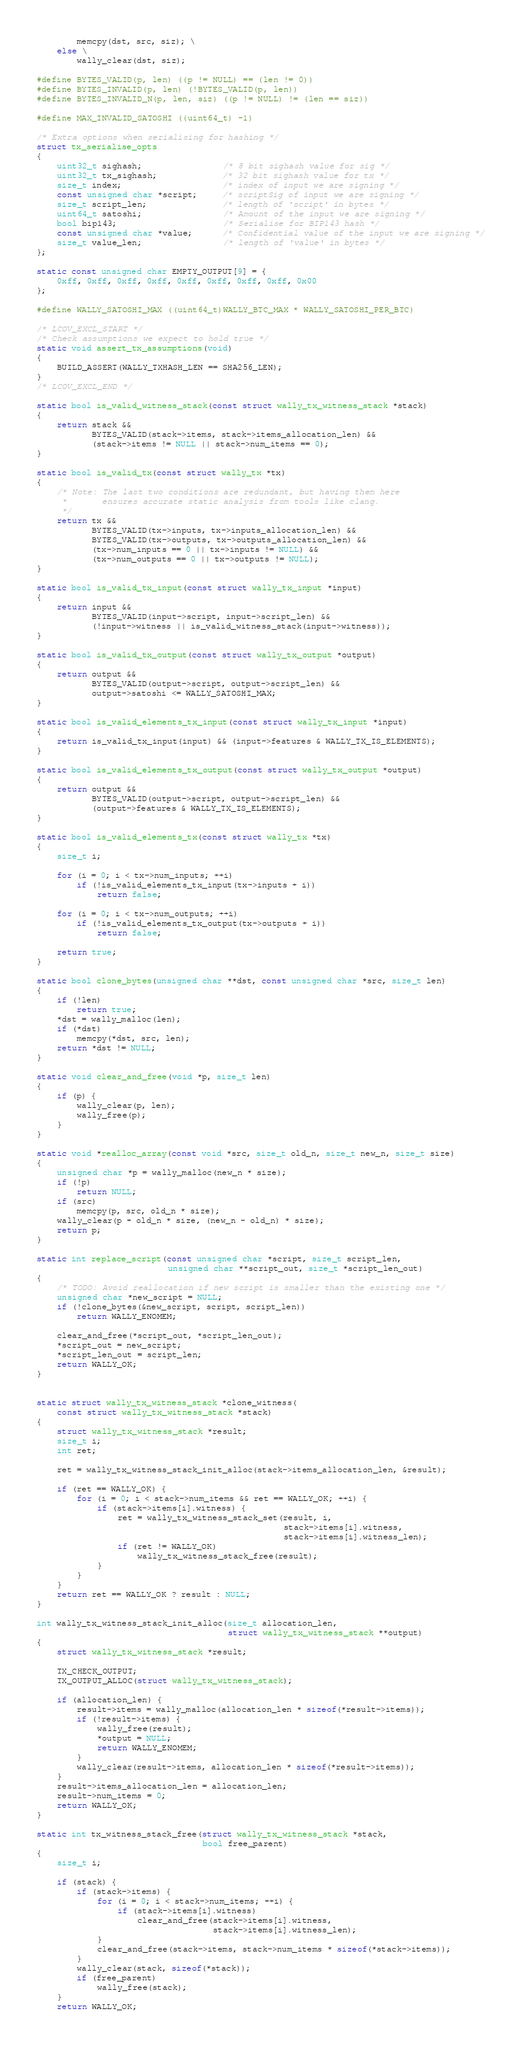<code> <loc_0><loc_0><loc_500><loc_500><_C_>        memcpy(dst, src, siz); \
    else \
        wally_clear(dst, siz);

#define BYTES_VALID(p, len) ((p != NULL) == (len != 0))
#define BYTES_INVALID(p, len) (!BYTES_VALID(p, len))
#define BYTES_INVALID_N(p, len, siz) ((p != NULL) != (len == siz))

#define MAX_INVALID_SATOSHI ((uint64_t) -1)

/* Extra options when serialising for hashing */
struct tx_serialise_opts
{
    uint32_t sighash;                /* 8 bit sighash value for sig */
    uint32_t tx_sighash;             /* 32 bit sighash value for tx */
    size_t index;                    /* index of input we are signing */
    const unsigned char *script;     /* scriptSig of input we are signing */
    size_t script_len;               /* length of 'script' in bytes */
    uint64_t satoshi;                /* Amount of the input we are signing */
    bool bip143;                     /* Serialise for BIP143 hash */
    const unsigned char *value;      /* Confidential value of the input we are signing */
    size_t value_len;                /* length of 'value' in bytes */
};

static const unsigned char EMPTY_OUTPUT[9] = {
    0xff, 0xff, 0xff, 0xff, 0xff, 0xff, 0xff, 0xff, 0x00
};

#define WALLY_SATOSHI_MAX ((uint64_t)WALLY_BTC_MAX * WALLY_SATOSHI_PER_BTC)

/* LCOV_EXCL_START */
/* Check assumptions we expect to hold true */
static void assert_tx_assumptions(void)
{
    BUILD_ASSERT(WALLY_TXHASH_LEN == SHA256_LEN);
}
/* LCOV_EXCL_END */

static bool is_valid_witness_stack(const struct wally_tx_witness_stack *stack)
{
    return stack &&
           BYTES_VALID(stack->items, stack->items_allocation_len) &&
           (stack->items != NULL || stack->num_items == 0);
}

static bool is_valid_tx(const struct wally_tx *tx)
{
    /* Note: The last two conditions are redundant, but having them here
     *       ensures accurate static analysis from tools like clang.
     */
    return tx &&
           BYTES_VALID(tx->inputs, tx->inputs_allocation_len) &&
           BYTES_VALID(tx->outputs, tx->outputs_allocation_len) &&
           (tx->num_inputs == 0 || tx->inputs != NULL) &&
           (tx->num_outputs == 0 || tx->outputs != NULL);
}

static bool is_valid_tx_input(const struct wally_tx_input *input)
{
    return input &&
           BYTES_VALID(input->script, input->script_len) &&
           (!input->witness || is_valid_witness_stack(input->witness));
}

static bool is_valid_tx_output(const struct wally_tx_output *output)
{
    return output &&
           BYTES_VALID(output->script, output->script_len) &&
           output->satoshi <= WALLY_SATOSHI_MAX;
}

static bool is_valid_elements_tx_input(const struct wally_tx_input *input)
{
    return is_valid_tx_input(input) && (input->features & WALLY_TX_IS_ELEMENTS);
}

static bool is_valid_elements_tx_output(const struct wally_tx_output *output)
{
    return output &&
           BYTES_VALID(output->script, output->script_len) &&
           (output->features & WALLY_TX_IS_ELEMENTS);
}

static bool is_valid_elements_tx(const struct wally_tx *tx)
{
    size_t i;

    for (i = 0; i < tx->num_inputs; ++i)
        if (!is_valid_elements_tx_input(tx->inputs + i))
            return false;

    for (i = 0; i < tx->num_outputs; ++i)
        if (!is_valid_elements_tx_output(tx->outputs + i))
            return false;

    return true;
}

static bool clone_bytes(unsigned char **dst, const unsigned char *src, size_t len)
{
    if (!len)
        return true;
    *dst = wally_malloc(len);
    if (*dst)
        memcpy(*dst, src, len);
    return *dst != NULL;
}

static void clear_and_free(void *p, size_t len)
{
    if (p) {
        wally_clear(p, len);
        wally_free(p);
    }
}

static void *realloc_array(const void *src, size_t old_n, size_t new_n, size_t size)
{
    unsigned char *p = wally_malloc(new_n * size);
    if (!p)
        return NULL;
    if (src)
        memcpy(p, src, old_n * size);
    wally_clear(p + old_n * size, (new_n - old_n) * size);
    return p;
}

static int replace_script(const unsigned char *script, size_t script_len,
                          unsigned char **script_out, size_t *script_len_out)
{
    /* TODO: Avoid reallocation if new script is smaller than the existing one */
    unsigned char *new_script = NULL;
    if (!clone_bytes(&new_script, script, script_len))
        return WALLY_ENOMEM;

    clear_and_free(*script_out, *script_len_out);
    *script_out = new_script;
    *script_len_out = script_len;
    return WALLY_OK;
}


static struct wally_tx_witness_stack *clone_witness(
    const struct wally_tx_witness_stack *stack)
{
    struct wally_tx_witness_stack *result;
    size_t i;
    int ret;

    ret = wally_tx_witness_stack_init_alloc(stack->items_allocation_len, &result);

    if (ret == WALLY_OK) {
        for (i = 0; i < stack->num_items && ret == WALLY_OK; ++i) {
            if (stack->items[i].witness) {
                ret = wally_tx_witness_stack_set(result, i,
                                                 stack->items[i].witness,
                                                 stack->items[i].witness_len);
                if (ret != WALLY_OK)
                    wally_tx_witness_stack_free(result);
            }
        }
    }
    return ret == WALLY_OK ? result : NULL;
}

int wally_tx_witness_stack_init_alloc(size_t allocation_len,
                                      struct wally_tx_witness_stack **output)
{
    struct wally_tx_witness_stack *result;

    TX_CHECK_OUTPUT;
    TX_OUTPUT_ALLOC(struct wally_tx_witness_stack);

    if (allocation_len) {
        result->items = wally_malloc(allocation_len * sizeof(*result->items));
        if (!result->items) {
            wally_free(result);
            *output = NULL;
            return WALLY_ENOMEM;
        }
        wally_clear(result->items, allocation_len * sizeof(*result->items));
    }
    result->items_allocation_len = allocation_len;
    result->num_items = 0;
    return WALLY_OK;
}

static int tx_witness_stack_free(struct wally_tx_witness_stack *stack,
                                 bool free_parent)
{
    size_t i;

    if (stack) {
        if (stack->items) {
            for (i = 0; i < stack->num_items; ++i) {
                if (stack->items[i].witness)
                    clear_and_free(stack->items[i].witness,
                                   stack->items[i].witness_len);
            }
            clear_and_free(stack->items, stack->num_items * sizeof(*stack->items));
        }
        wally_clear(stack, sizeof(*stack));
        if (free_parent)
            wally_free(stack);
    }
    return WALLY_OK;</code> 